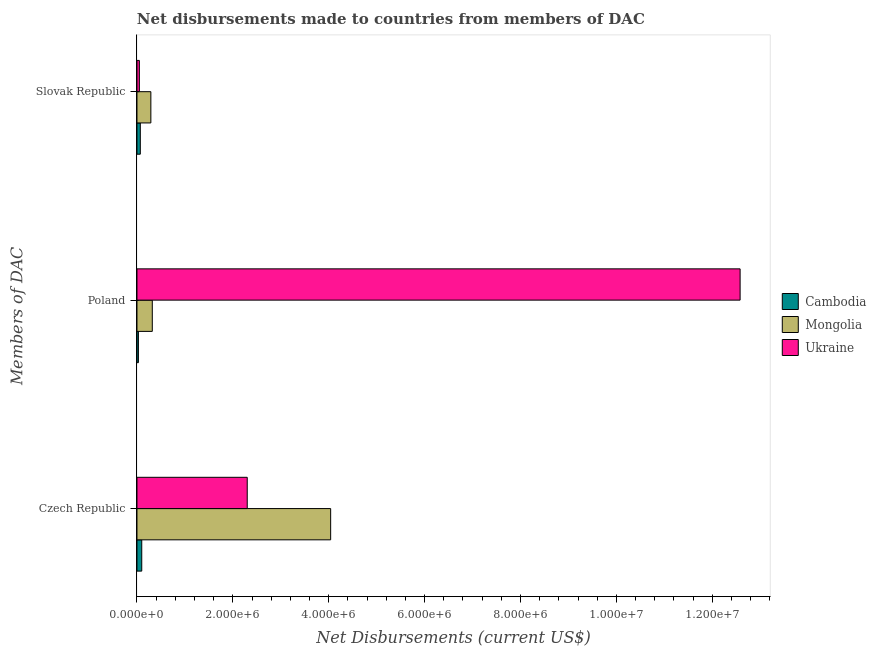Are the number of bars per tick equal to the number of legend labels?
Give a very brief answer. Yes. Are the number of bars on each tick of the Y-axis equal?
Ensure brevity in your answer.  Yes. How many bars are there on the 3rd tick from the bottom?
Your answer should be very brief. 3. What is the label of the 1st group of bars from the top?
Make the answer very short. Slovak Republic. What is the net disbursements made by slovak republic in Mongolia?
Ensure brevity in your answer.  2.90e+05. Across all countries, what is the maximum net disbursements made by slovak republic?
Offer a very short reply. 2.90e+05. Across all countries, what is the minimum net disbursements made by czech republic?
Make the answer very short. 1.00e+05. In which country was the net disbursements made by czech republic maximum?
Provide a short and direct response. Mongolia. In which country was the net disbursements made by czech republic minimum?
Provide a short and direct response. Cambodia. What is the total net disbursements made by poland in the graph?
Offer a very short reply. 1.29e+07. What is the difference between the net disbursements made by poland in Ukraine and that in Mongolia?
Offer a very short reply. 1.23e+07. What is the difference between the net disbursements made by slovak republic in Mongolia and the net disbursements made by poland in Cambodia?
Give a very brief answer. 2.60e+05. What is the average net disbursements made by czech republic per country?
Make the answer very short. 2.15e+06. What is the difference between the net disbursements made by slovak republic and net disbursements made by poland in Ukraine?
Provide a short and direct response. -1.25e+07. What is the ratio of the net disbursements made by poland in Ukraine to that in Mongolia?
Ensure brevity in your answer.  39.31. Is the net disbursements made by poland in Mongolia less than that in Ukraine?
Your answer should be very brief. Yes. What is the difference between the highest and the second highest net disbursements made by poland?
Offer a terse response. 1.23e+07. What is the difference between the highest and the lowest net disbursements made by slovak republic?
Offer a very short reply. 2.40e+05. In how many countries, is the net disbursements made by czech republic greater than the average net disbursements made by czech republic taken over all countries?
Keep it short and to the point. 2. What does the 1st bar from the top in Slovak Republic represents?
Provide a short and direct response. Ukraine. What does the 1st bar from the bottom in Poland represents?
Keep it short and to the point. Cambodia. How many bars are there?
Provide a succinct answer. 9. How many countries are there in the graph?
Your answer should be very brief. 3. Are the values on the major ticks of X-axis written in scientific E-notation?
Ensure brevity in your answer.  Yes. Does the graph contain any zero values?
Provide a short and direct response. No. Does the graph contain grids?
Provide a short and direct response. No. Where does the legend appear in the graph?
Provide a succinct answer. Center right. What is the title of the graph?
Offer a very short reply. Net disbursements made to countries from members of DAC. What is the label or title of the X-axis?
Your response must be concise. Net Disbursements (current US$). What is the label or title of the Y-axis?
Give a very brief answer. Members of DAC. What is the Net Disbursements (current US$) in Mongolia in Czech Republic?
Make the answer very short. 4.04e+06. What is the Net Disbursements (current US$) in Ukraine in Czech Republic?
Your response must be concise. 2.30e+06. What is the Net Disbursements (current US$) of Cambodia in Poland?
Offer a terse response. 3.00e+04. What is the Net Disbursements (current US$) of Ukraine in Poland?
Ensure brevity in your answer.  1.26e+07. What is the Net Disbursements (current US$) in Cambodia in Slovak Republic?
Provide a short and direct response. 7.00e+04. What is the Net Disbursements (current US$) of Mongolia in Slovak Republic?
Your answer should be compact. 2.90e+05. What is the Net Disbursements (current US$) in Ukraine in Slovak Republic?
Offer a terse response. 5.00e+04. Across all Members of DAC, what is the maximum Net Disbursements (current US$) in Cambodia?
Your answer should be compact. 1.00e+05. Across all Members of DAC, what is the maximum Net Disbursements (current US$) in Mongolia?
Your answer should be very brief. 4.04e+06. Across all Members of DAC, what is the maximum Net Disbursements (current US$) in Ukraine?
Your response must be concise. 1.26e+07. Across all Members of DAC, what is the minimum Net Disbursements (current US$) of Mongolia?
Keep it short and to the point. 2.90e+05. Across all Members of DAC, what is the minimum Net Disbursements (current US$) of Ukraine?
Your answer should be very brief. 5.00e+04. What is the total Net Disbursements (current US$) of Cambodia in the graph?
Give a very brief answer. 2.00e+05. What is the total Net Disbursements (current US$) of Mongolia in the graph?
Your response must be concise. 4.65e+06. What is the total Net Disbursements (current US$) of Ukraine in the graph?
Your answer should be very brief. 1.49e+07. What is the difference between the Net Disbursements (current US$) of Cambodia in Czech Republic and that in Poland?
Your answer should be very brief. 7.00e+04. What is the difference between the Net Disbursements (current US$) in Mongolia in Czech Republic and that in Poland?
Make the answer very short. 3.72e+06. What is the difference between the Net Disbursements (current US$) of Ukraine in Czech Republic and that in Poland?
Your response must be concise. -1.03e+07. What is the difference between the Net Disbursements (current US$) of Cambodia in Czech Republic and that in Slovak Republic?
Your answer should be very brief. 3.00e+04. What is the difference between the Net Disbursements (current US$) in Mongolia in Czech Republic and that in Slovak Republic?
Your answer should be compact. 3.75e+06. What is the difference between the Net Disbursements (current US$) of Ukraine in Czech Republic and that in Slovak Republic?
Give a very brief answer. 2.25e+06. What is the difference between the Net Disbursements (current US$) in Mongolia in Poland and that in Slovak Republic?
Offer a terse response. 3.00e+04. What is the difference between the Net Disbursements (current US$) in Ukraine in Poland and that in Slovak Republic?
Provide a succinct answer. 1.25e+07. What is the difference between the Net Disbursements (current US$) of Cambodia in Czech Republic and the Net Disbursements (current US$) of Mongolia in Poland?
Provide a succinct answer. -2.20e+05. What is the difference between the Net Disbursements (current US$) of Cambodia in Czech Republic and the Net Disbursements (current US$) of Ukraine in Poland?
Keep it short and to the point. -1.25e+07. What is the difference between the Net Disbursements (current US$) of Mongolia in Czech Republic and the Net Disbursements (current US$) of Ukraine in Poland?
Make the answer very short. -8.54e+06. What is the difference between the Net Disbursements (current US$) in Mongolia in Czech Republic and the Net Disbursements (current US$) in Ukraine in Slovak Republic?
Offer a very short reply. 3.99e+06. What is the difference between the Net Disbursements (current US$) of Cambodia in Poland and the Net Disbursements (current US$) of Ukraine in Slovak Republic?
Provide a succinct answer. -2.00e+04. What is the difference between the Net Disbursements (current US$) of Mongolia in Poland and the Net Disbursements (current US$) of Ukraine in Slovak Republic?
Provide a short and direct response. 2.70e+05. What is the average Net Disbursements (current US$) of Cambodia per Members of DAC?
Provide a succinct answer. 6.67e+04. What is the average Net Disbursements (current US$) of Mongolia per Members of DAC?
Provide a succinct answer. 1.55e+06. What is the average Net Disbursements (current US$) of Ukraine per Members of DAC?
Ensure brevity in your answer.  4.98e+06. What is the difference between the Net Disbursements (current US$) of Cambodia and Net Disbursements (current US$) of Mongolia in Czech Republic?
Offer a very short reply. -3.94e+06. What is the difference between the Net Disbursements (current US$) of Cambodia and Net Disbursements (current US$) of Ukraine in Czech Republic?
Your response must be concise. -2.20e+06. What is the difference between the Net Disbursements (current US$) of Mongolia and Net Disbursements (current US$) of Ukraine in Czech Republic?
Provide a succinct answer. 1.74e+06. What is the difference between the Net Disbursements (current US$) of Cambodia and Net Disbursements (current US$) of Ukraine in Poland?
Make the answer very short. -1.26e+07. What is the difference between the Net Disbursements (current US$) in Mongolia and Net Disbursements (current US$) in Ukraine in Poland?
Offer a terse response. -1.23e+07. What is the difference between the Net Disbursements (current US$) in Cambodia and Net Disbursements (current US$) in Mongolia in Slovak Republic?
Give a very brief answer. -2.20e+05. What is the difference between the Net Disbursements (current US$) of Cambodia and Net Disbursements (current US$) of Ukraine in Slovak Republic?
Your answer should be very brief. 2.00e+04. What is the difference between the Net Disbursements (current US$) in Mongolia and Net Disbursements (current US$) in Ukraine in Slovak Republic?
Your response must be concise. 2.40e+05. What is the ratio of the Net Disbursements (current US$) of Cambodia in Czech Republic to that in Poland?
Your response must be concise. 3.33. What is the ratio of the Net Disbursements (current US$) in Mongolia in Czech Republic to that in Poland?
Your response must be concise. 12.62. What is the ratio of the Net Disbursements (current US$) of Ukraine in Czech Republic to that in Poland?
Your answer should be very brief. 0.18. What is the ratio of the Net Disbursements (current US$) of Cambodia in Czech Republic to that in Slovak Republic?
Your answer should be compact. 1.43. What is the ratio of the Net Disbursements (current US$) of Mongolia in Czech Republic to that in Slovak Republic?
Your response must be concise. 13.93. What is the ratio of the Net Disbursements (current US$) of Cambodia in Poland to that in Slovak Republic?
Ensure brevity in your answer.  0.43. What is the ratio of the Net Disbursements (current US$) of Mongolia in Poland to that in Slovak Republic?
Give a very brief answer. 1.1. What is the ratio of the Net Disbursements (current US$) of Ukraine in Poland to that in Slovak Republic?
Give a very brief answer. 251.6. What is the difference between the highest and the second highest Net Disbursements (current US$) of Cambodia?
Your answer should be compact. 3.00e+04. What is the difference between the highest and the second highest Net Disbursements (current US$) in Mongolia?
Provide a succinct answer. 3.72e+06. What is the difference between the highest and the second highest Net Disbursements (current US$) of Ukraine?
Provide a succinct answer. 1.03e+07. What is the difference between the highest and the lowest Net Disbursements (current US$) of Mongolia?
Offer a very short reply. 3.75e+06. What is the difference between the highest and the lowest Net Disbursements (current US$) of Ukraine?
Keep it short and to the point. 1.25e+07. 